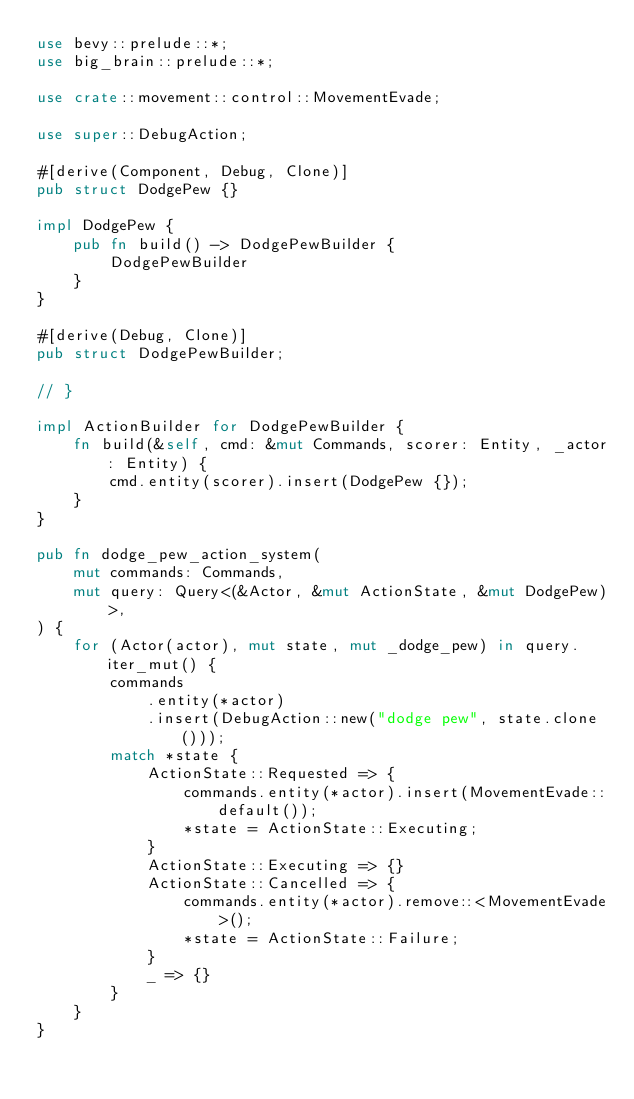Convert code to text. <code><loc_0><loc_0><loc_500><loc_500><_Rust_>use bevy::prelude::*;
use big_brain::prelude::*;

use crate::movement::control::MovementEvade;

use super::DebugAction;

#[derive(Component, Debug, Clone)]
pub struct DodgePew {}

impl DodgePew {
    pub fn build() -> DodgePewBuilder {
        DodgePewBuilder
    }
}

#[derive(Debug, Clone)]
pub struct DodgePewBuilder;

// }

impl ActionBuilder for DodgePewBuilder {
    fn build(&self, cmd: &mut Commands, scorer: Entity, _actor: Entity) {
        cmd.entity(scorer).insert(DodgePew {});
    }
}

pub fn dodge_pew_action_system(
    mut commands: Commands,
    mut query: Query<(&Actor, &mut ActionState, &mut DodgePew)>,
) {
    for (Actor(actor), mut state, mut _dodge_pew) in query.iter_mut() {
        commands
            .entity(*actor)
            .insert(DebugAction::new("dodge pew", state.clone()));
        match *state {
            ActionState::Requested => {
                commands.entity(*actor).insert(MovementEvade::default());
                *state = ActionState::Executing;
            }
            ActionState::Executing => {}
            ActionState::Cancelled => {
                commands.entity(*actor).remove::<MovementEvade>();
                *state = ActionState::Failure;
            }
            _ => {}
        }
    }
}
</code> 